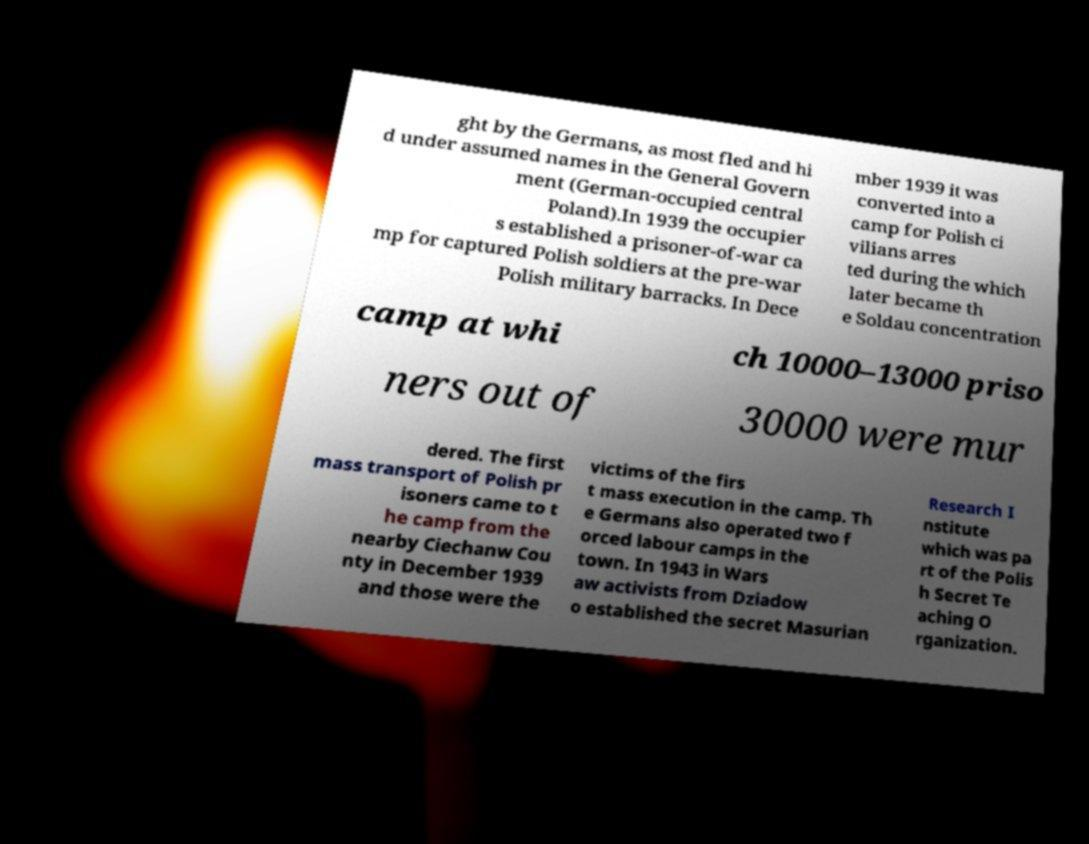Can you accurately transcribe the text from the provided image for me? ght by the Germans, as most fled and hi d under assumed names in the General Govern ment (German-occupied central Poland).In 1939 the occupier s established a prisoner-of-war ca mp for captured Polish soldiers at the pre-war Polish military barracks. In Dece mber 1939 it was converted into a camp for Polish ci vilians arres ted during the which later became th e Soldau concentration camp at whi ch 10000–13000 priso ners out of 30000 were mur dered. The first mass transport of Polish pr isoners came to t he camp from the nearby Ciechanw Cou nty in December 1939 and those were the victims of the firs t mass execution in the camp. Th e Germans also operated two f orced labour camps in the town. In 1943 in Wars aw activists from Dziadow o established the secret Masurian Research I nstitute which was pa rt of the Polis h Secret Te aching O rganization. 